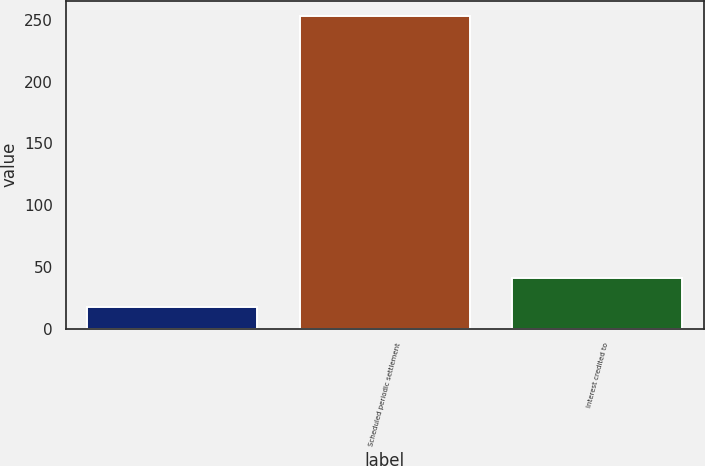Convert chart to OTSL. <chart><loc_0><loc_0><loc_500><loc_500><bar_chart><ecel><fcel>Scheduled periodic settlement<fcel>Interest credited to<nl><fcel>18<fcel>253<fcel>41.5<nl></chart> 